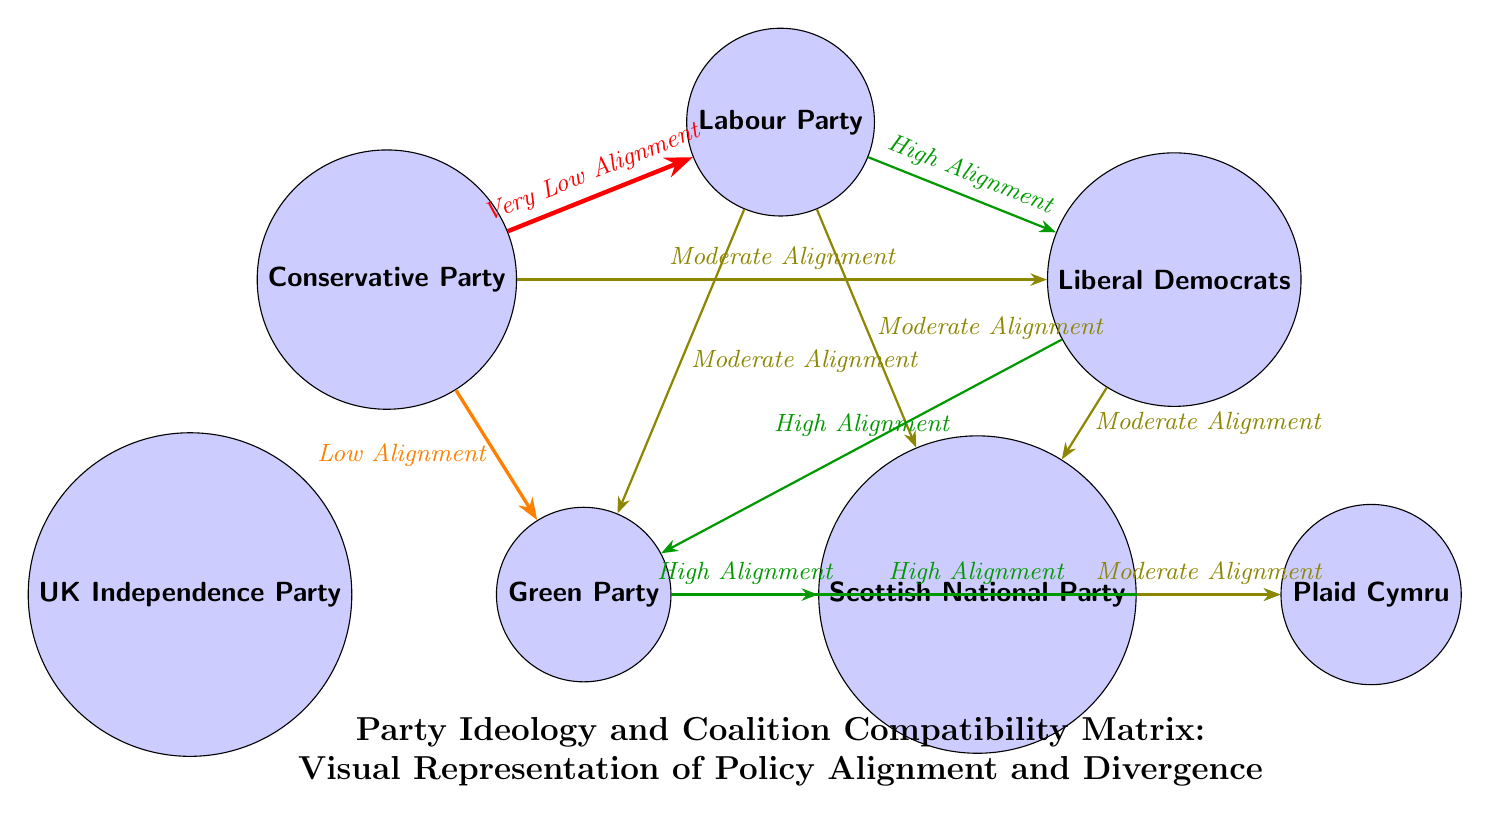What is the alignment level between the Conservative Party and the Labour Party? The diagram indicates a "Very Low Alignment" relationship between the Conservative Party and the Labour Party, which is represented by a red arrow connecting the two nodes.
Answer: Very Low Alignment How many parties are represented in the diagram? The diagram comprises six nodes, each representing a different party: Conservative Party, Labour Party, Liberal Democrats, Green Party, UK Independence Party, Scottish National Party, and Plaid Cymru.
Answer: 6 Which party aligns most closely with the Green Party? The diagram shows a "High Alignment" connection between the Green Party and the Scottish National Party, indicating they share significant policy overlap.
Answer: Scottish National Party What is the relationship between the Labour Party and the Liberal Democrats? The diagram depicts a "High Alignment" relationship between the Labour Party and the Liberal Democrats, indicated by a green arrow connecting the two nodes.
Answer: High Alignment Which parties have a "Moderate Alignment" with the Liberal Democrats? The Liberal Democrats have "Moderate Alignment" connections with three parties: Conservative Party, Labour Party, and Scottish National Party. These connections are represented by olive-colored arrows.
Answer: Conservative Party, Labour Party, Scottish National Party How does the UK Independence Party compare in alignment with other parties? The UK Independence Party has a "Low Alignment" with the Conservative Party and "Very Low Alignment" with the Labour Party, while it is disconnected from other parties. This shows its alignment is comparatively lesser.
Answer: Low Alignment Which party has no connection to the UK Independence Party? The diagram shows that the UK Independence Party is disconnected from the Scottish National Party and Plaid Cymru, signifying no alignment relationships indicated by arrows.
Answer: Scottish National Party, Plaid Cymru What does the overall title of the diagram suggest about its content? The title "Party Ideology and Coalition Compatibility Matrix: Visual Representation of Policy Alignment and Divergence" indicates that the diagram is designed to illustrate how various political parties align or diverge in terms of ideology and potential coalition compatibility.
Answer: Visual Representation of Policy Alignment What type of diagram structure is used to represent party relationships? The structure used is a matrix-like arrangement with nodes representing parties and directed arrows indicating the nature and level of policy alignment between them.
Answer: Matrix-like arrangement 